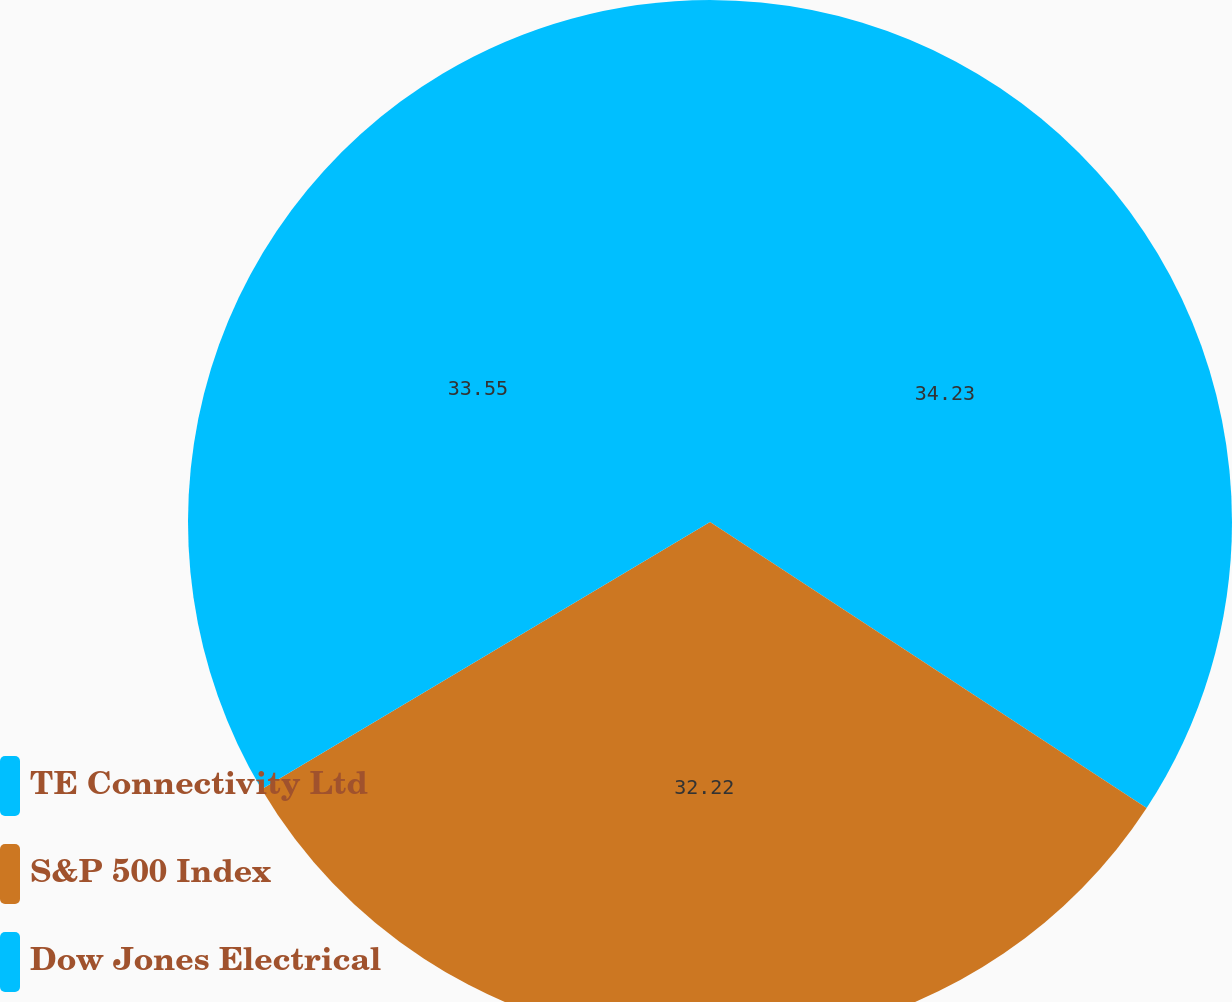<chart> <loc_0><loc_0><loc_500><loc_500><pie_chart><fcel>TE Connectivity Ltd<fcel>S&P 500 Index<fcel>Dow Jones Electrical<nl><fcel>34.23%<fcel>32.22%<fcel>33.55%<nl></chart> 